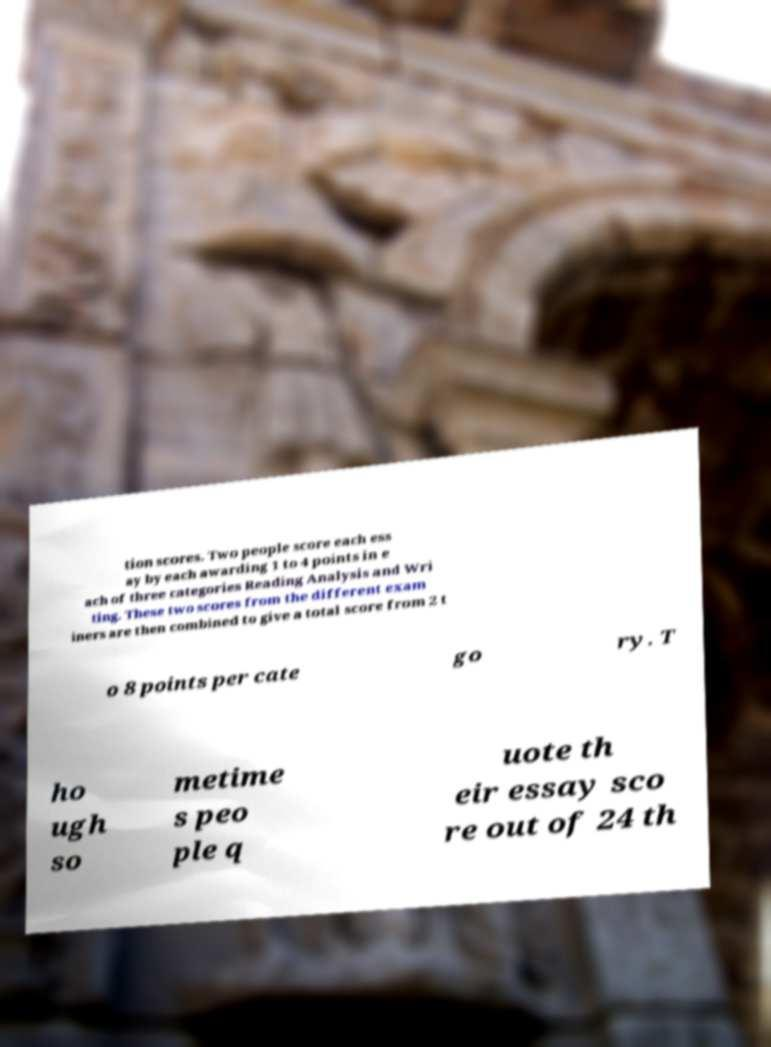Can you read and provide the text displayed in the image?This photo seems to have some interesting text. Can you extract and type it out for me? tion scores. Two people score each ess ay by each awarding 1 to 4 points in e ach of three categories Reading Analysis and Wri ting. These two scores from the different exam iners are then combined to give a total score from 2 t o 8 points per cate go ry. T ho ugh so metime s peo ple q uote th eir essay sco re out of 24 th 